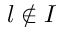Convert formula to latex. <formula><loc_0><loc_0><loc_500><loc_500>l \notin { I }</formula> 